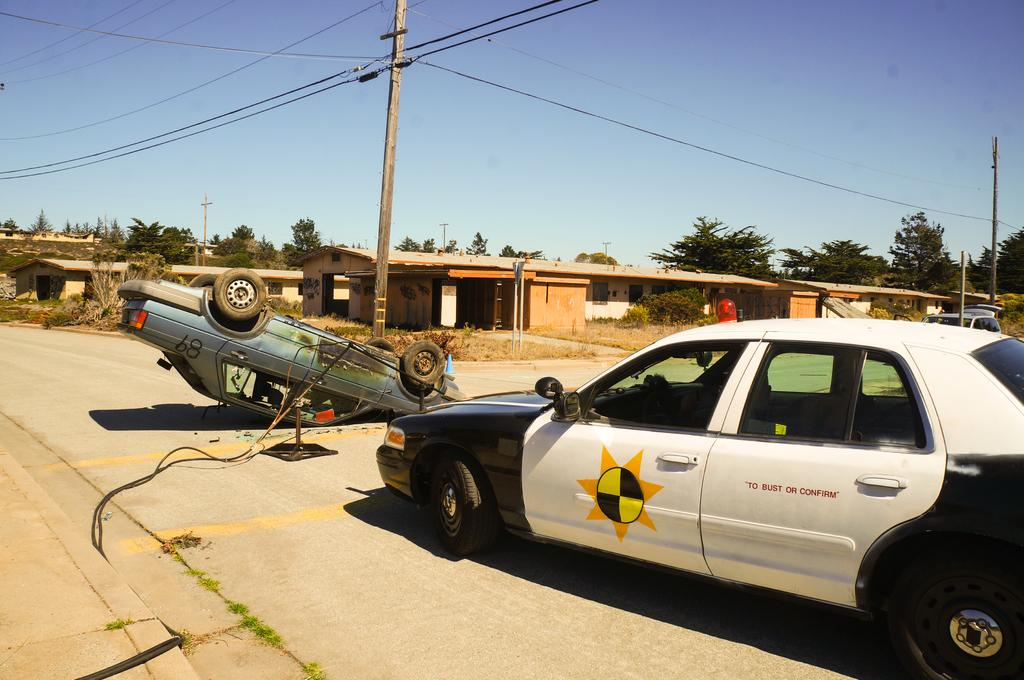Provide a one-sentence caption for the provided image. A car with "To bust or confirm" on the side is sitting in front of a car that. 